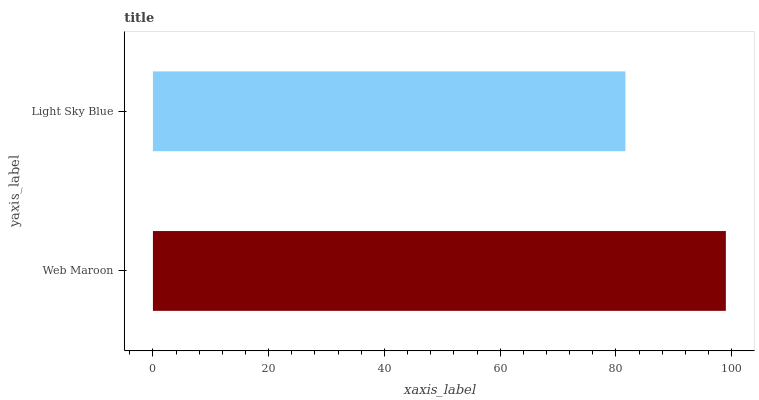Is Light Sky Blue the minimum?
Answer yes or no. Yes. Is Web Maroon the maximum?
Answer yes or no. Yes. Is Light Sky Blue the maximum?
Answer yes or no. No. Is Web Maroon greater than Light Sky Blue?
Answer yes or no. Yes. Is Light Sky Blue less than Web Maroon?
Answer yes or no. Yes. Is Light Sky Blue greater than Web Maroon?
Answer yes or no. No. Is Web Maroon less than Light Sky Blue?
Answer yes or no. No. Is Web Maroon the high median?
Answer yes or no. Yes. Is Light Sky Blue the low median?
Answer yes or no. Yes. Is Light Sky Blue the high median?
Answer yes or no. No. Is Web Maroon the low median?
Answer yes or no. No. 